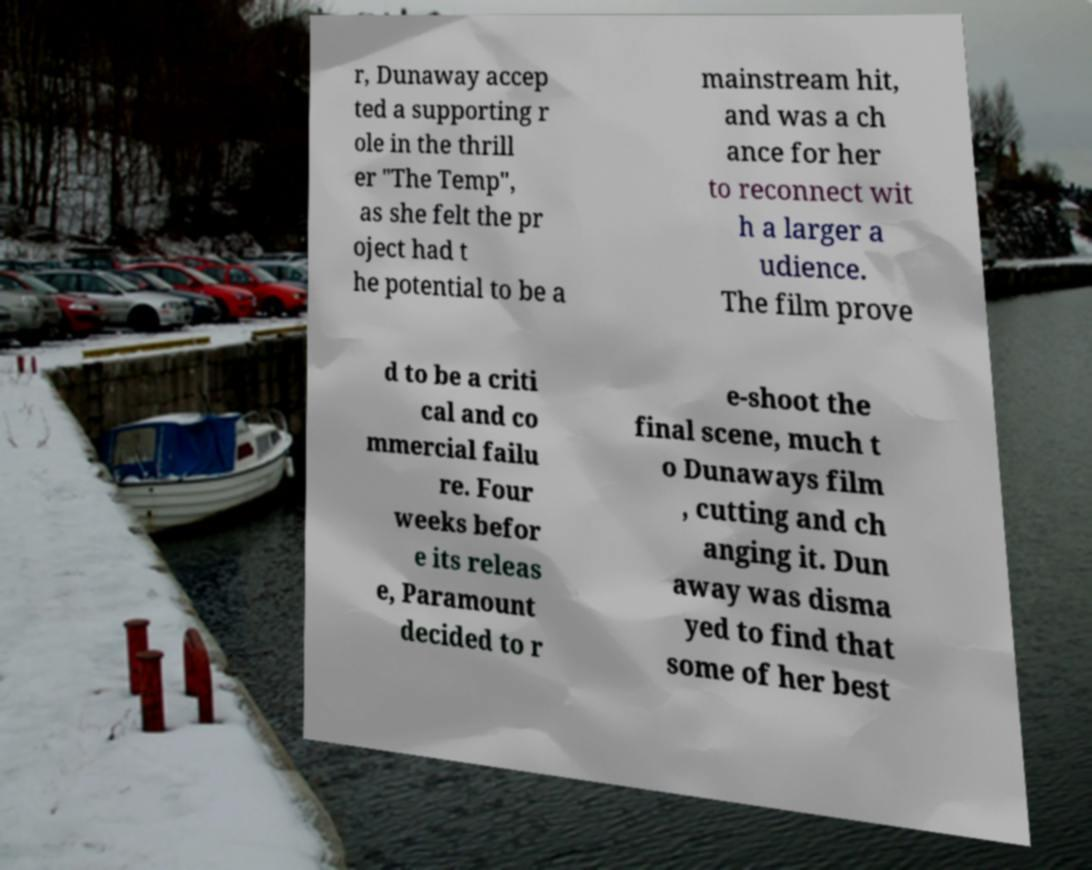Could you extract and type out the text from this image? r, Dunaway accep ted a supporting r ole in the thrill er "The Temp", as she felt the pr oject had t he potential to be a mainstream hit, and was a ch ance for her to reconnect wit h a larger a udience. The film prove d to be a criti cal and co mmercial failu re. Four weeks befor e its releas e, Paramount decided to r e-shoot the final scene, much t o Dunaways film , cutting and ch anging it. Dun away was disma yed to find that some of her best 